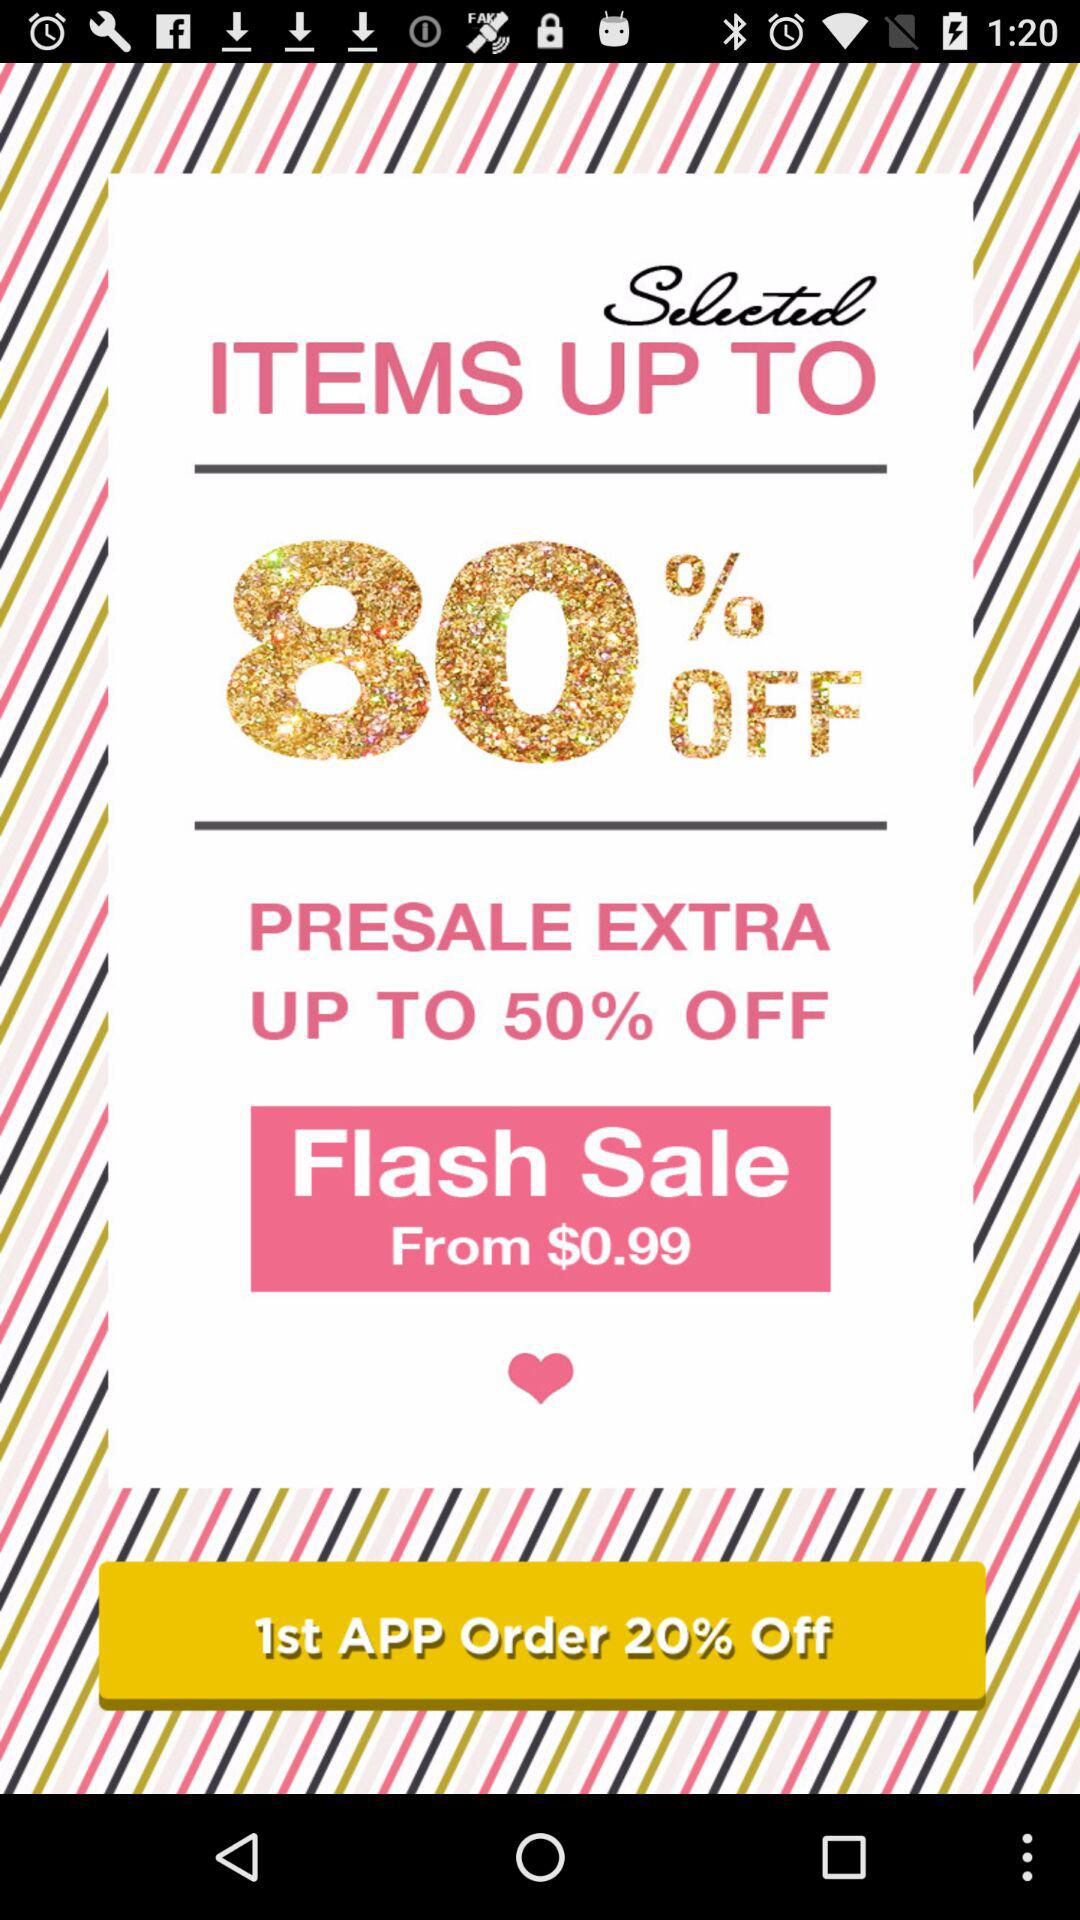How many percent off is the first app order?
Answer the question using a single word or phrase. 20% 